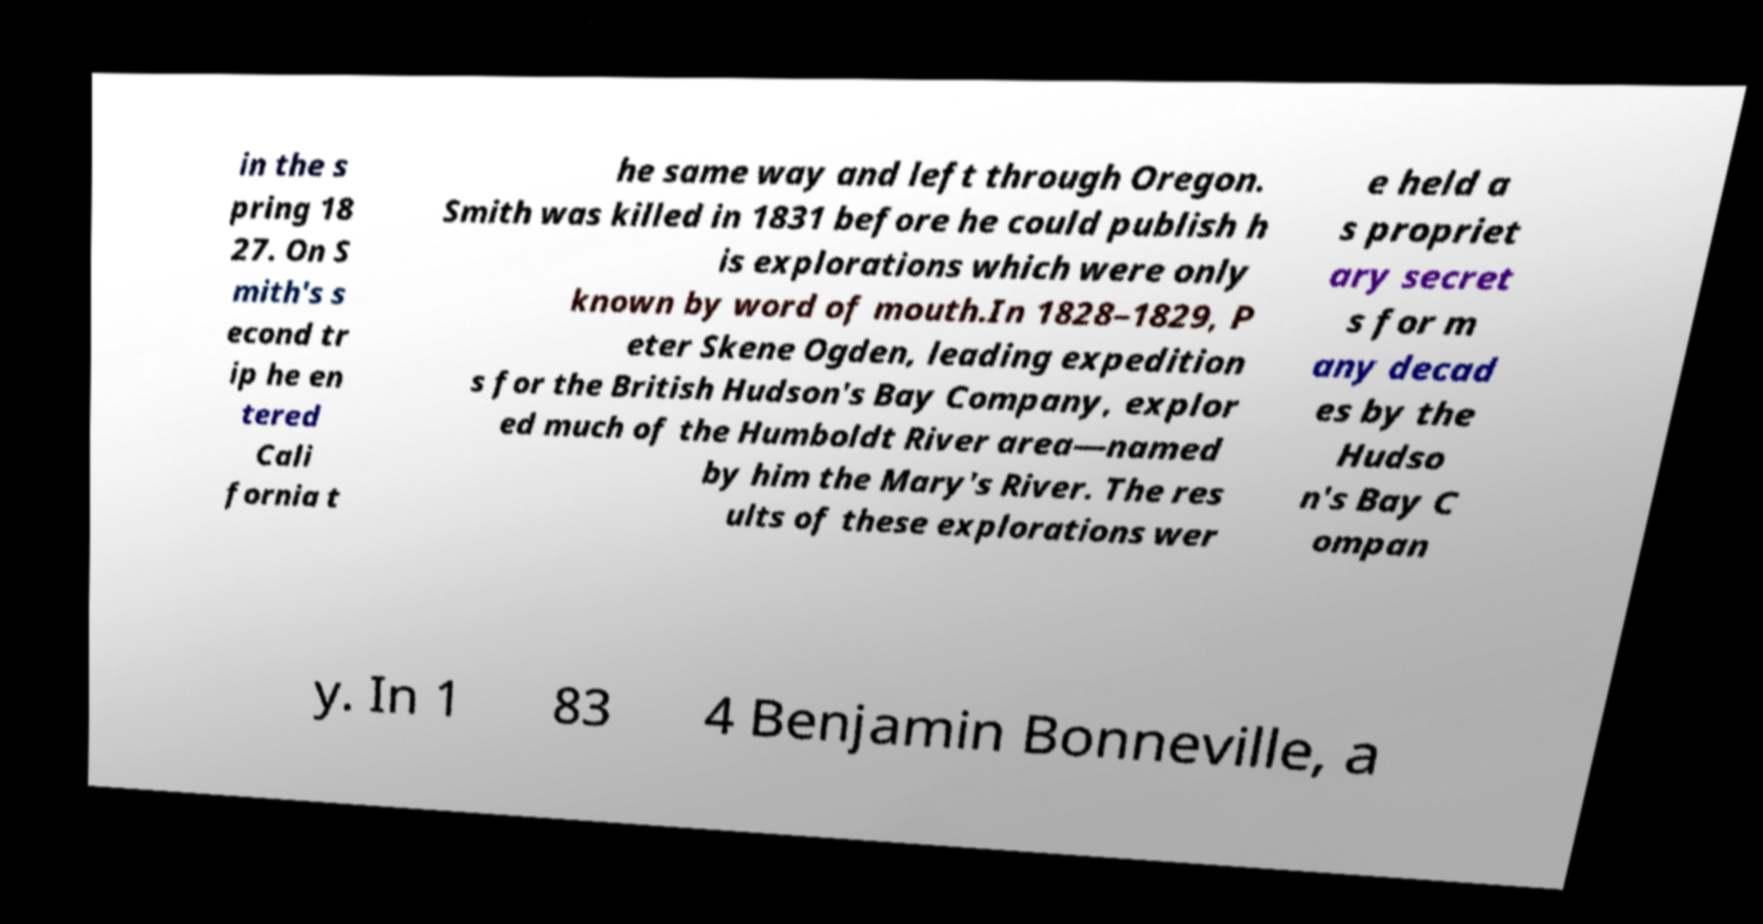Please identify and transcribe the text found in this image. in the s pring 18 27. On S mith's s econd tr ip he en tered Cali fornia t he same way and left through Oregon. Smith was killed in 1831 before he could publish h is explorations which were only known by word of mouth.In 1828–1829, P eter Skene Ogden, leading expedition s for the British Hudson's Bay Company, explor ed much of the Humboldt River area—named by him the Mary's River. The res ults of these explorations wer e held a s propriet ary secret s for m any decad es by the Hudso n's Bay C ompan y. In 1 83 4 Benjamin Bonneville, a 